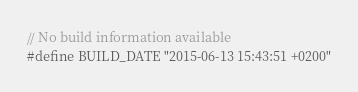Convert code to text. <code><loc_0><loc_0><loc_500><loc_500><_C_>// No build information available
#define BUILD_DATE "2015-06-13 15:43:51 +0200"
</code> 